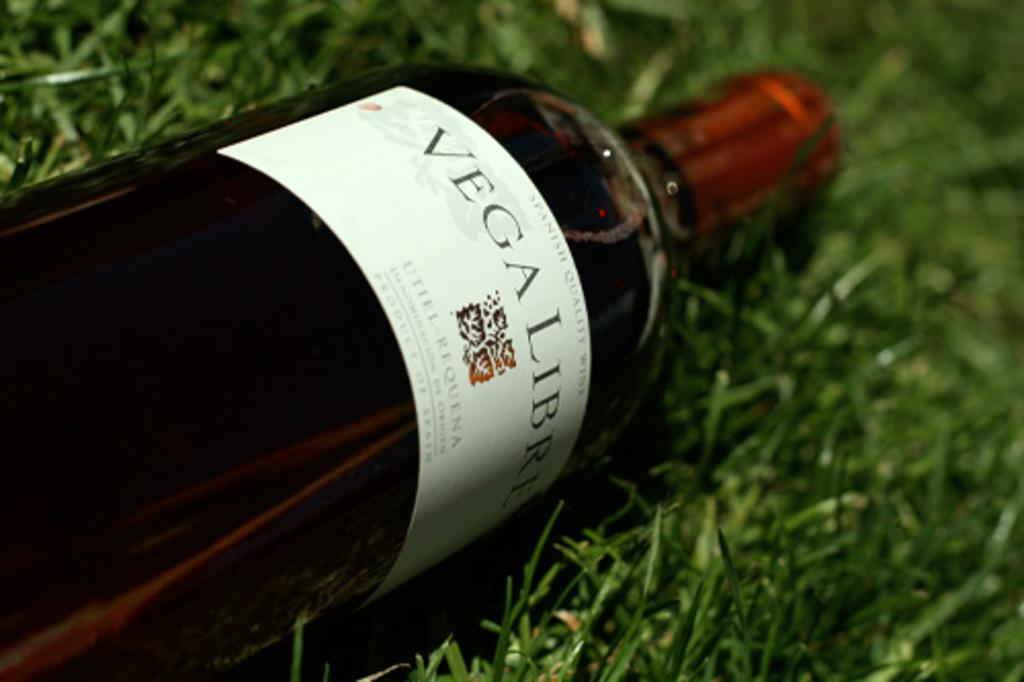<image>
Summarize the visual content of the image. A bottle with a white label that reads Vega Libre with a red top on it. 